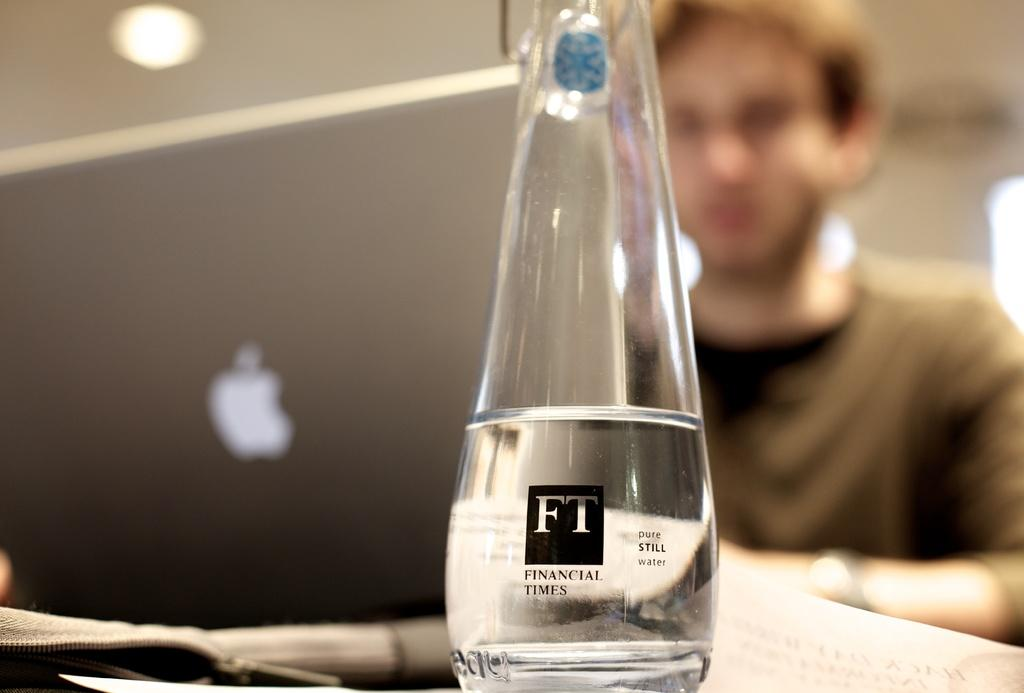What object can be seen in the image? There is a bottle in the image. Can you describe the setting of the image? In the background of the image, there is a person and a laptop. What might the person be doing with the laptop? It is not clear from the image what the person is doing with the laptop. What is the cause of the field in the image? There is no field present in the image; it only features a bottle, a person, and a laptop. 